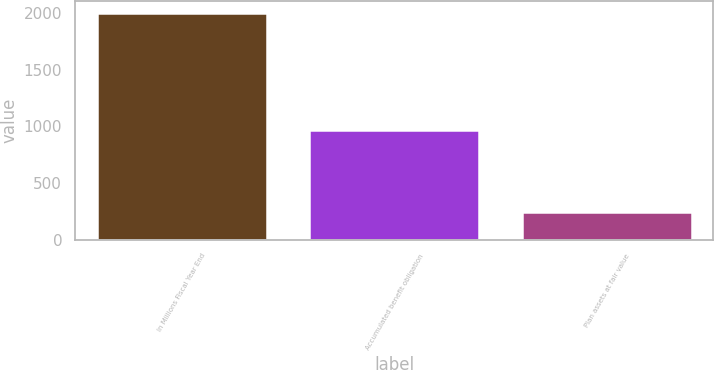Convert chart to OTSL. <chart><loc_0><loc_0><loc_500><loc_500><bar_chart><fcel>In Millions Fiscal Year End<fcel>Accumulated benefit obligation<fcel>Plan assets at fair value<nl><fcel>2005<fcel>971<fcel>242<nl></chart> 